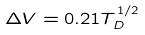<formula> <loc_0><loc_0><loc_500><loc_500>\Delta V = 0 . 2 1 T _ { D } ^ { 1 / 2 }</formula> 